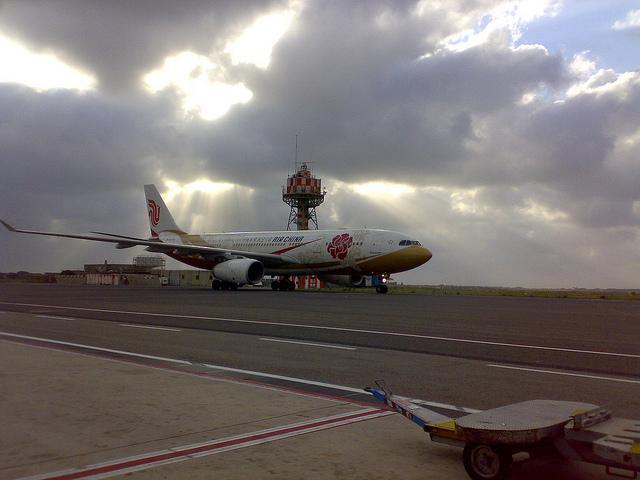How many levels on this bus are red?
Give a very brief answer. 0. 